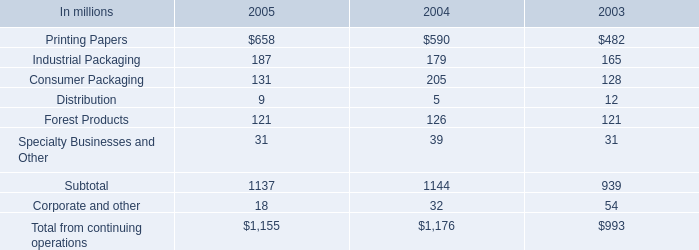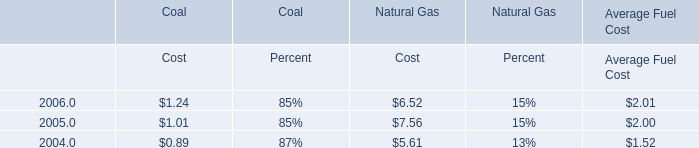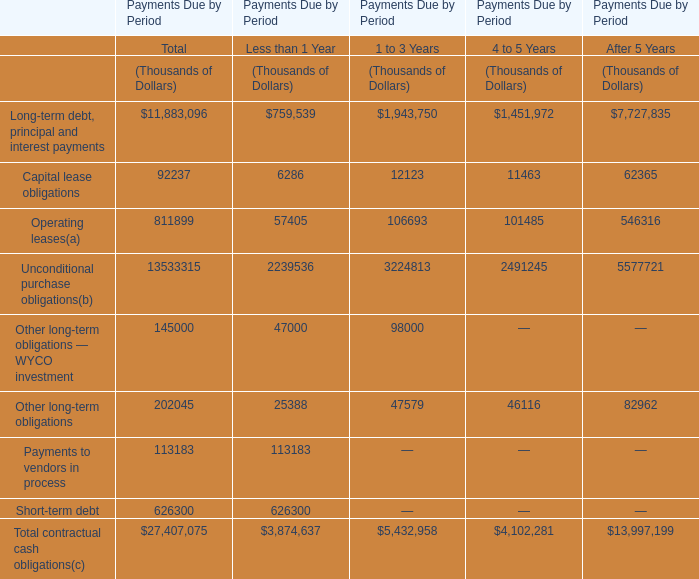what was the ratio of the increase in the cash used for the working capital from 2004 to 2005 
Computations: (591 / 86)
Answer: 6.87209. 